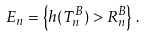Convert formula to latex. <formula><loc_0><loc_0><loc_500><loc_500>E _ { n } = \left \{ h ( T ^ { B } _ { n } ) > R ^ { B } _ { n } \right \} \, .</formula> 